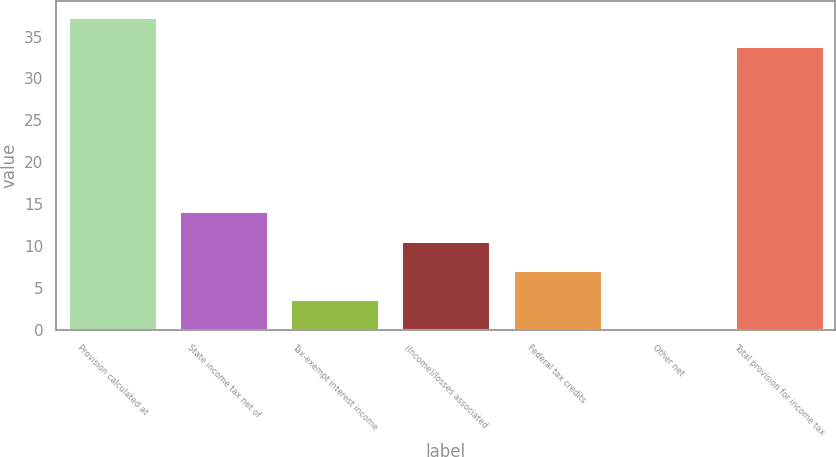Convert chart to OTSL. <chart><loc_0><loc_0><loc_500><loc_500><bar_chart><fcel>Provision calculated at<fcel>State income tax net of<fcel>Tax-exempt interest income<fcel>(Income)/losses associated<fcel>Federal tax credits<fcel>Other net<fcel>Total provision for income tax<nl><fcel>37.38<fcel>14.12<fcel>3.68<fcel>10.64<fcel>7.16<fcel>0.2<fcel>33.9<nl></chart> 